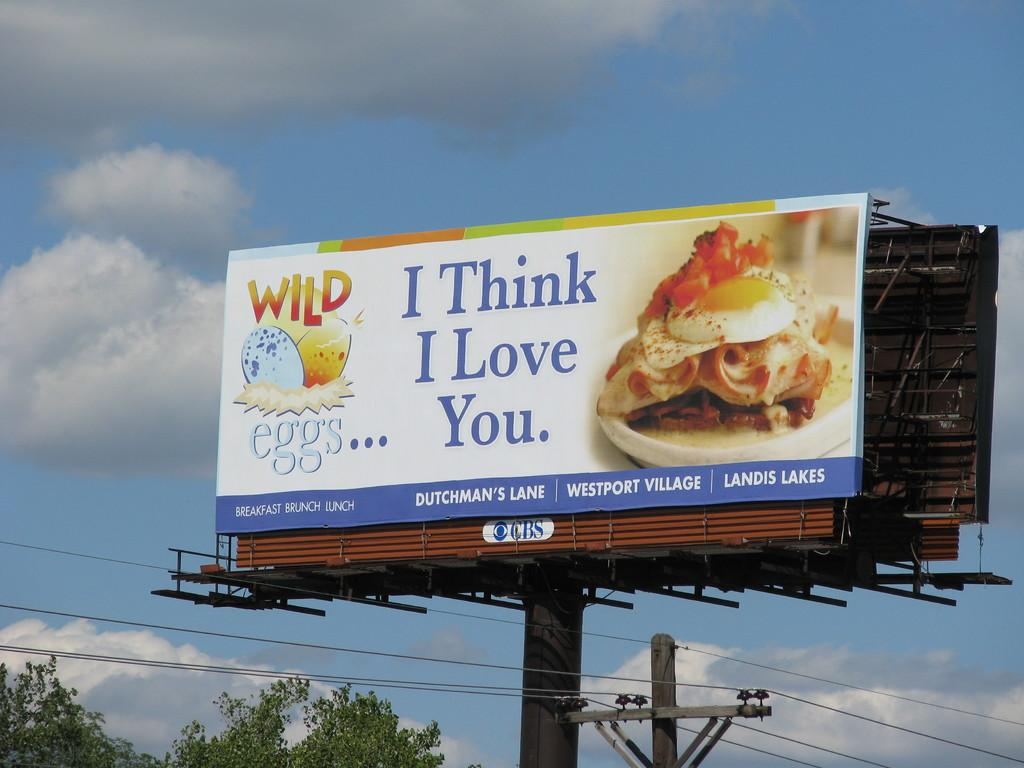What structures can be seen in the image? There are poles in the image. What is written or depicted on the boards in the image? There are boards with text and images in the image. What else can be seen connecting the poles in the image? There are wires visible in the image. What type of vegetation is at the bottom of the image? There are trees at the bottom of the image. What is visible in the background of the image? The sky with clouds is visible in the image. What time does the clock show in the image? There is no clock present in the image, so it is not possible to determine the time. 